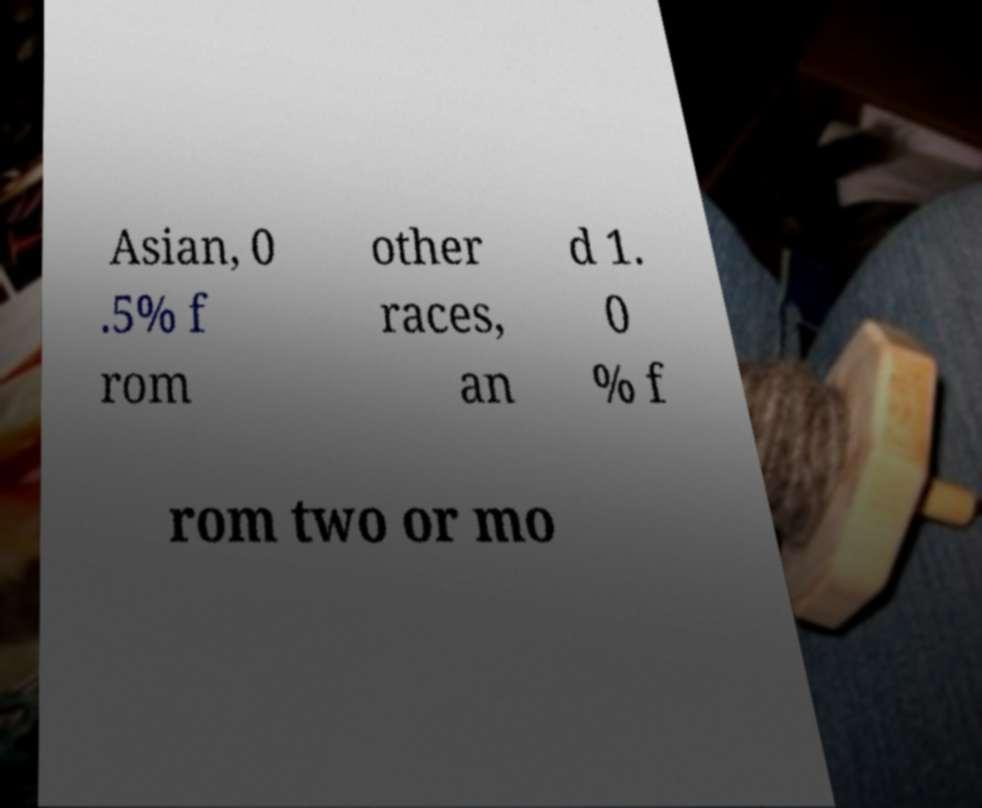Could you assist in decoding the text presented in this image and type it out clearly? Asian, 0 .5% f rom other races, an d 1. 0 % f rom two or mo 